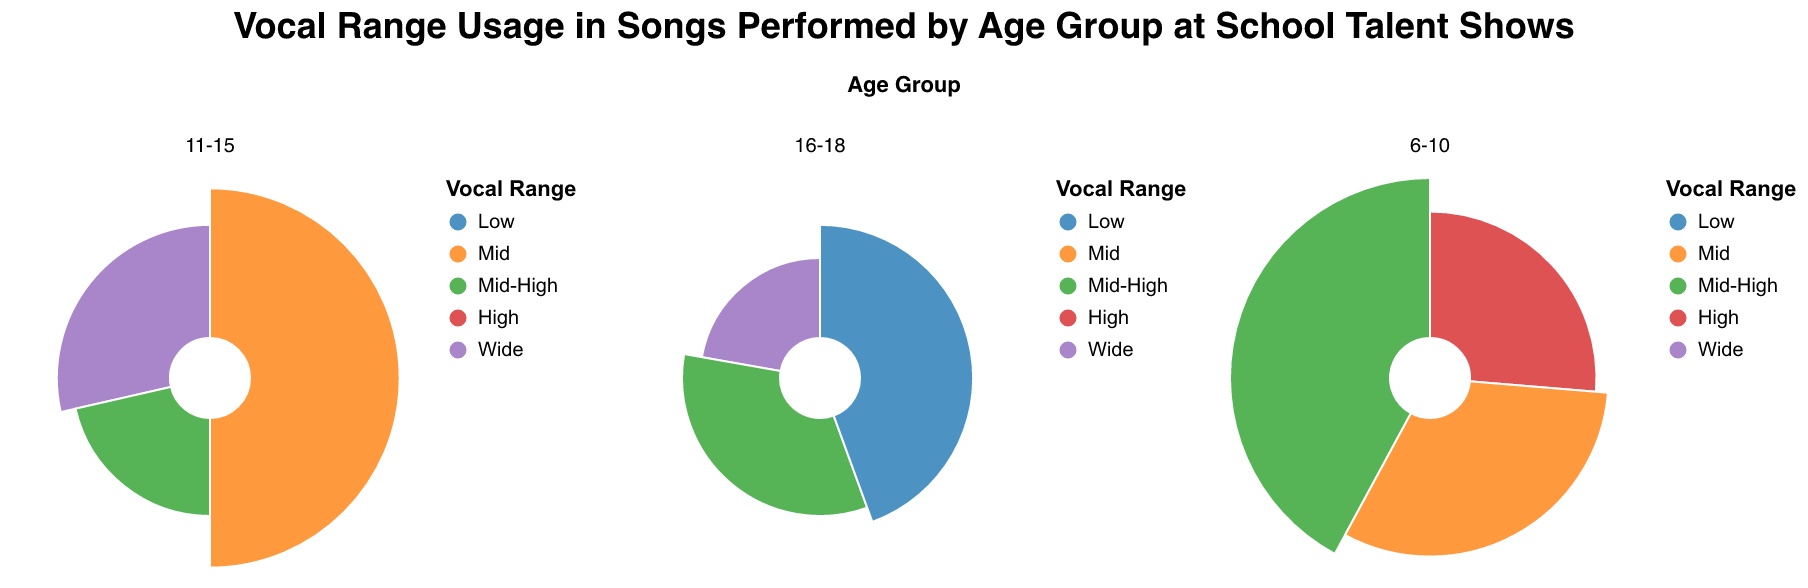what is the title of the figure? The title of the figure is shown at the top. The title is: "Vocal Range Usage in Songs Performed by Age Group at School Talent Shows".
Answer: Vocal Range Usage in Songs Performed by Age Group at School Talent Shows Which Age Group has the song with the highest Performance Count? By looking at the radial sections for each Age Group, we see that the song with the highest Performance Count is in the 6-10 Age Group with "Let It Go (Frozen)" having a count of 8.
Answer: 6-10 How many songs in the 11-15 Age Group have a Mid Vocal Range? Look at the section for Age Group 11-15 and count the songs with the 'Mid' label. There is one song "Believer (Imagine Dragons)" with a Mid Vocal Range.
Answer: 1 Which Vocal Range is least used across all Age Groups? Identify the Vocal Range with the smallest total Performance Counts across all subplots. 'Wide' is used only 6 times in 11-15 Age Group and 2 times in 16-18 Age Group, which is a total of 6.
Answer: Wide How many songs in the 16-18 Age Group have a Performance Count higher than 2? Within the 16-18 Age Group section, count the number of songs with Performance Count greater than 2. These songs are: "Rolling in the Deep (Adele)" with 3 and "Bad Guy (Billie Eilish)" with 4, totaling 2 songs.
Answer: 2 What's the most common Vocal Range in the 6-10 Age Group? Find the Vocal Range segment for the 6-10 Age Group that occupies the largest arc. "Mid-High" appears most frequently with "Let It Go (Frozen)" having 8 counts.
Answer: Mid-High Which song in the 16-18 Age Group has the fewest performances? Look at the songs listed under the 16-18 Age Group and identify the one with the lowest Performance Count. "Bohemian Rhapsody (Queen)" has the fewest performance count with 2.
Answer: Bohemian Rhapsody (Queen) What's the total Performance Count of songs with Mid-High Vocal Range in the entire figure? Sum the Performance Counts for all 'Mid-High' songs across all Age Groups: "Let It Go (Frozen)" (8) + "Shallow (Lady Gaga & Bradley Cooper)" (3) + "Rolling in the Deep (Adele)" (3) = 14.
Answer: 14 Compare the total Performance Count of 'High' versus 'Low' Vocal Range across all Age Groups. Which one is higher? Sum Performance Counts for 'High' and 'Low' Vocal Ranges: High: "Twinkle Twinkle Little Star" (5), Low: "Bad Guy (Billie Eilish)" (4). High (5) is greater than Low (4).
Answer: High 